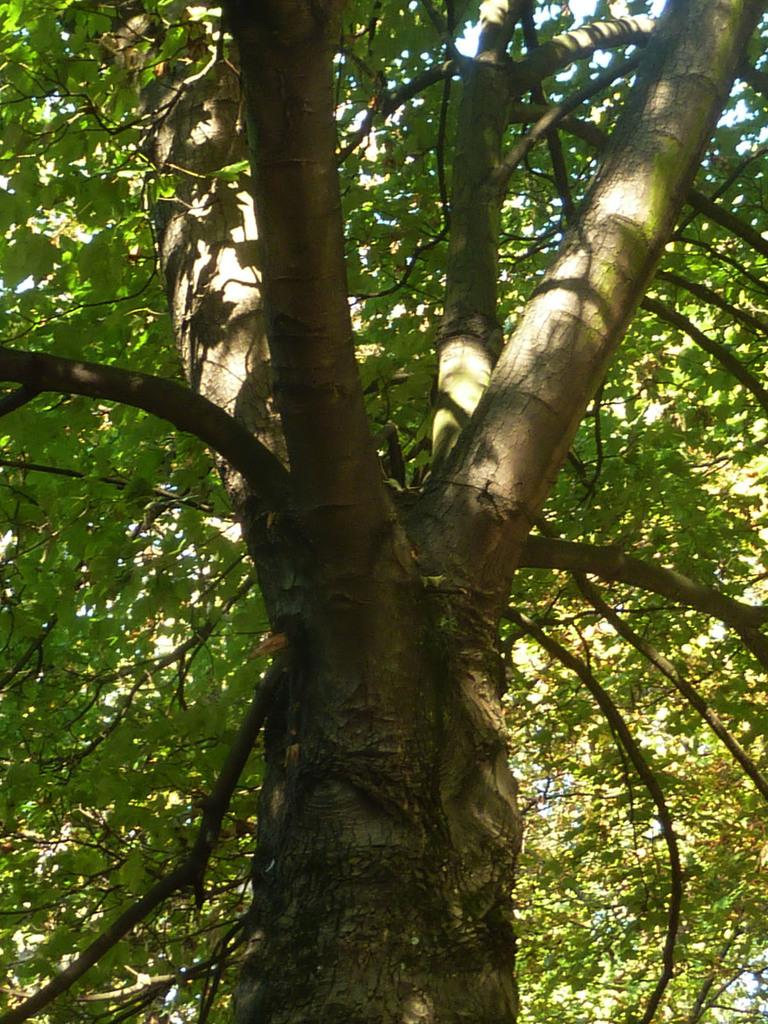What type of vegetation can be seen in the image? There are trees in the image. What part of the natural environment is visible in the image? The sky is visible in the background of the image. What type of wound can be seen on the cat in the image? There is no cat present in the image, and therefore no wound can be observed. What month is depicted in the image? The image does not depict a specific month; it only shows trees and the sky. 